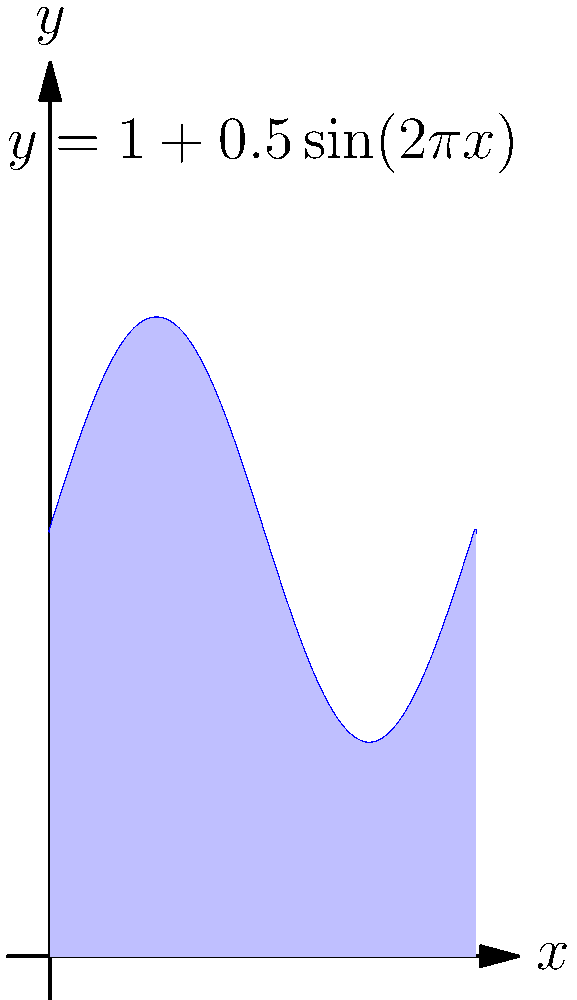As a field intelligence officer, you're tasked with calculating the total area of a disputed territory. The boundary of this territory is represented by the function $y = 1 + 0.5\sin(2\pi x)$ from $x = 0$ to $x = 1$, as shown in the map above. Using integral calculus, determine the total area of this disputed territory. Round your answer to three decimal places. To find the area of the disputed territory, we need to calculate the definite integral of the given function from 0 to 1. Here's the step-by-step process:

1) The area is given by the integral:

   $$A = \int_0^1 [1 + 0.5\sin(2\pi x)] dx$$

2) Let's break this into two parts:

   $$A = \int_0^1 1 dx + \int_0^1 0.5\sin(2\pi x) dx$$

3) The first part is straightforward:

   $$\int_0^1 1 dx = x\Big|_0^1 = 1 - 0 = 1$$

4) For the second part, we use the substitution $u = 2\pi x$, $du = 2\pi dx$:

   $$\int_0^1 0.5\sin(2\pi x) dx = \frac{1}{4\pi} \int_0^{2\pi} \sin(u) du$$

5) We know that $\int \sin(u) du = -\cos(u) + C$, so:

   $$\frac{1}{4\pi} \int_0^{2\pi} \sin(u) du = \frac{1}{4\pi} [-\cos(u)]_0^{2\pi}$$
   $$= \frac{1}{4\pi} [-\cos(2\pi) + \cos(0)] = \frac{1}{4\pi} [-1 + 1] = 0$$

6) Adding the results from steps 3 and 5:

   $$A = 1 + 0 = 1$$

Therefore, the total area of the disputed territory is 1 square unit.
Answer: 1.000 square units 